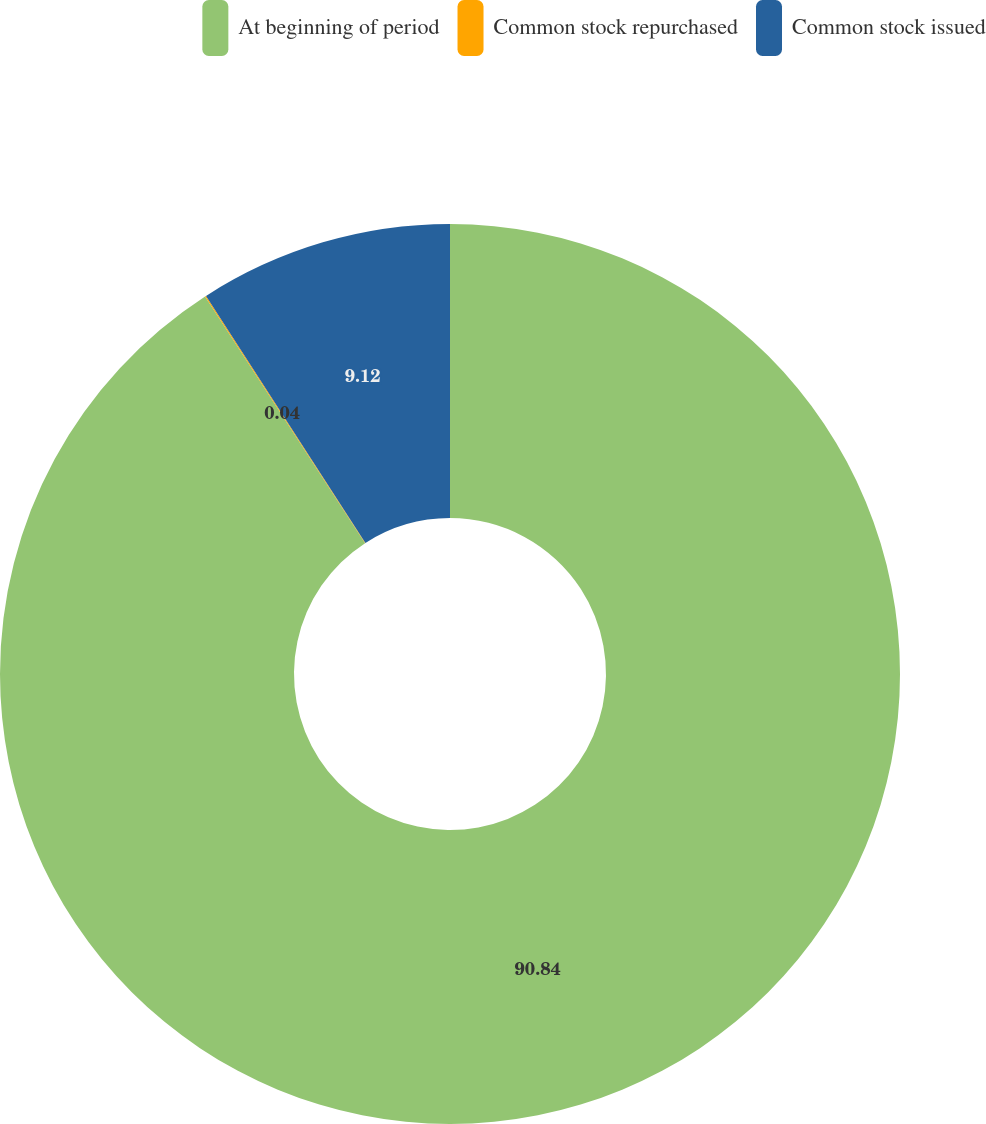<chart> <loc_0><loc_0><loc_500><loc_500><pie_chart><fcel>At beginning of period<fcel>Common stock repurchased<fcel>Common stock issued<nl><fcel>90.84%<fcel>0.04%<fcel>9.12%<nl></chart> 